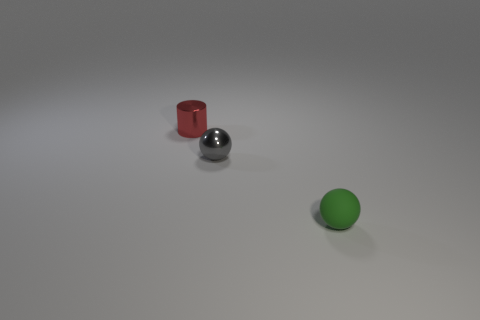How many metallic balls are there?
Give a very brief answer. 1. The object that is in front of the sphere behind the green matte ball is made of what material?
Offer a terse response. Rubber. There is a thing that is the same material as the tiny red cylinder; what color is it?
Offer a very short reply. Gray. There is a object that is right of the tiny gray sphere; is it the same size as the shiny object in front of the small red metal cylinder?
Provide a succinct answer. Yes. How many balls are gray objects or tiny rubber objects?
Your response must be concise. 2. Do the object behind the gray metallic sphere and the gray sphere have the same material?
Keep it short and to the point. Yes. How many other objects are the same size as the green matte ball?
Give a very brief answer. 2. How many large objects are cyan matte cylinders or shiny cylinders?
Provide a short and direct response. 0. Is the matte sphere the same color as the tiny shiny cylinder?
Your answer should be compact. No. Is the number of tiny metallic balls that are behind the tiny gray thing greater than the number of green rubber spheres in front of the tiny green matte ball?
Provide a short and direct response. No. 